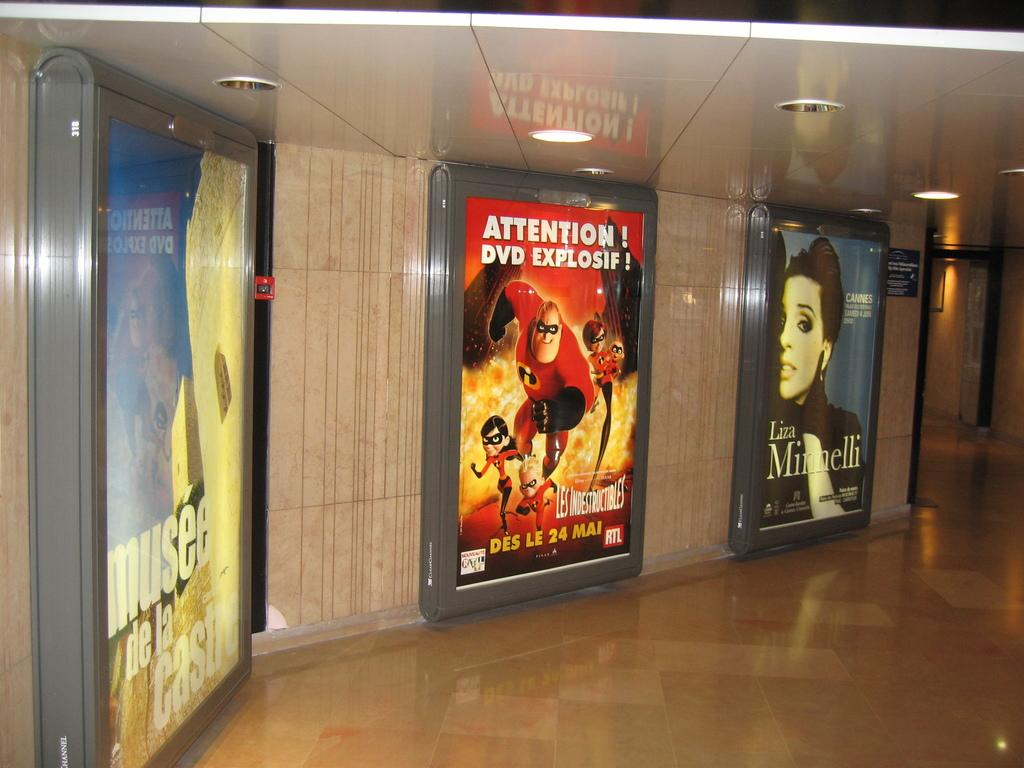What is on the wall in the image? There are posters on a wall in the image. What can be seen on the posters? The posters have pictures and text on them. What part of the room is visible in the image? The floor is visible in the image. What is above the room in the image? There is a roof in the image. What type of lighting is present in the image? Ceiling lights are present in the image. Where is the mom standing with the cows and celery in the image? There is no mom, cows, or celery present in the image. 